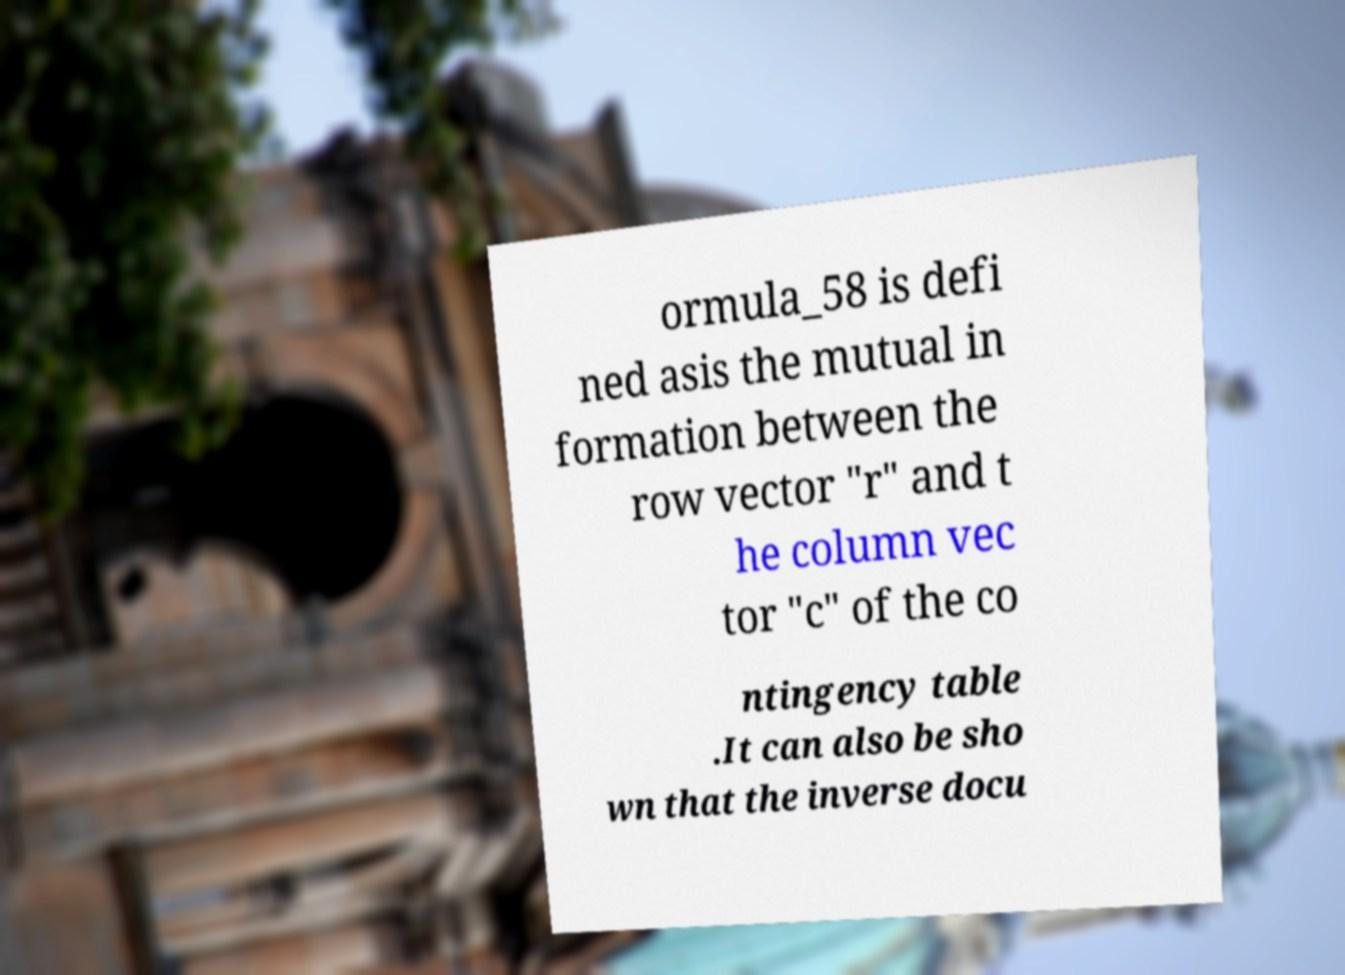Could you assist in decoding the text presented in this image and type it out clearly? ormula_58 is defi ned asis the mutual in formation between the row vector "r" and t he column vec tor "c" of the co ntingency table .It can also be sho wn that the inverse docu 